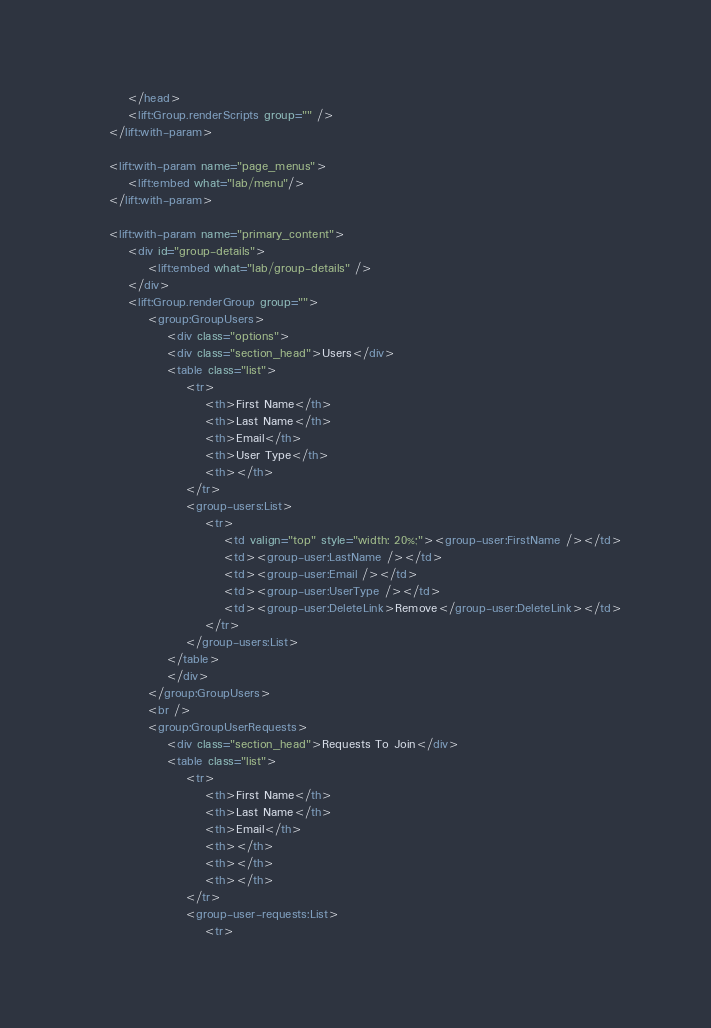<code> <loc_0><loc_0><loc_500><loc_500><_HTML_>		</head>
		<lift:Group.renderScripts group="" />
	</lift:with-param>
	
    <lift:with-param name="page_menus">
        <lift:embed what="lab/menu"/>
    </lift:with-param>    
	
	<lift:with-param name="primary_content">
		<div id="group-details">
			<lift:embed what="lab/group-details" />
		</div>
		<lift:Group.renderGroup group="">
			<group:GroupUsers>
				<div class="options">
                <div class="section_head">Users</div>
				<table class="list">
					<tr>
						<th>First Name</th>
						<th>Last Name</th>
						<th>Email</th>
						<th>User Type</th>
						<th></th>
					</tr>
					<group-users:List>
						<tr>
							<td valign="top" style="width: 20%;"><group-user:FirstName /></td>
							<td><group-user:LastName /></td>
							<td><group-user:Email /></td>
							<td><group-user:UserType /></td>
							<td><group-user:DeleteLink>Remove</group-user:DeleteLink></td>
						</tr>
					</group-users:List>
				</table>
                </div>
			</group:GroupUsers>
			<br />
			<group:GroupUserRequests>
				<div class="section_head">Requests To Join</div>
				<table class="list">
					<tr>
						<th>First Name</th>
						<th>Last Name</th>
						<th>Email</th>
						<th></th>
						<th></th>
						<th></th>
					</tr>
					<group-user-requests:List>
						<tr></code> 